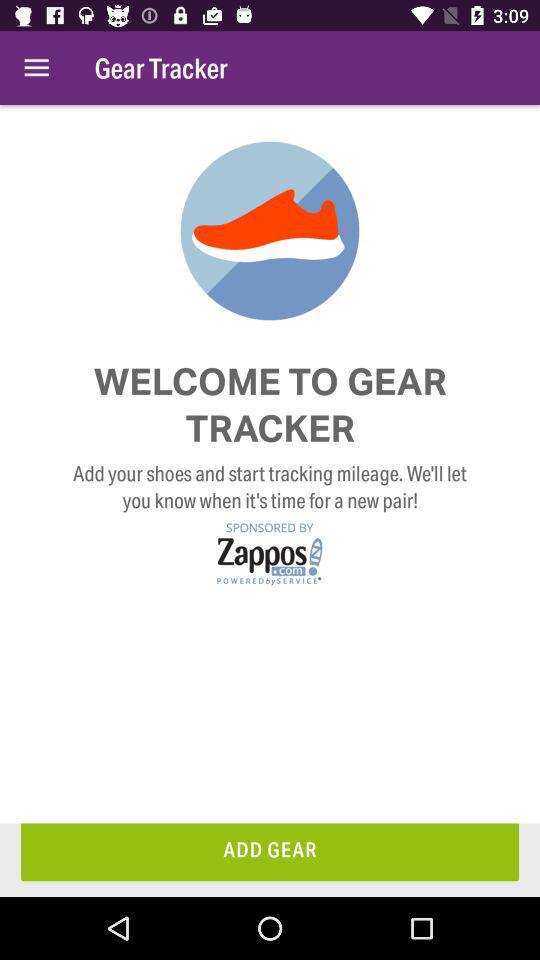What is the application name? The application name is "Gear Tracker". 